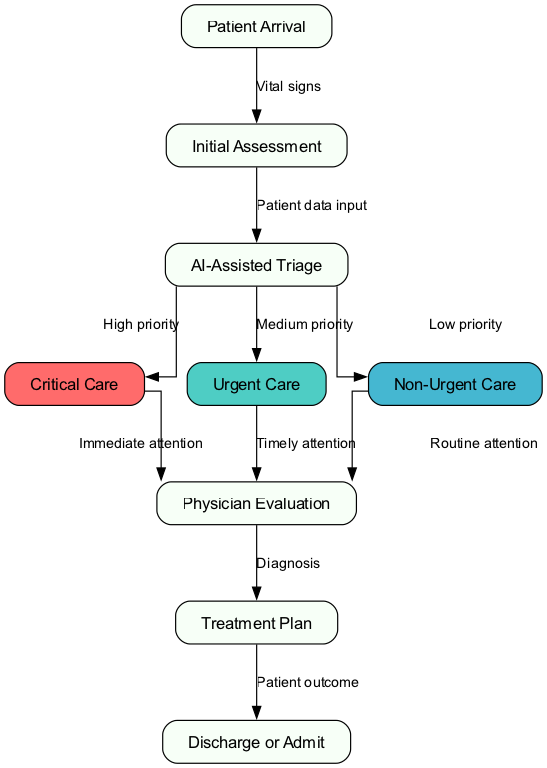What is the first step in the triage process? The flowchart begins with "Patient Arrival" as the first node in the triage process.
Answer: Patient Arrival How many nodes are present in this flowchart? By counting the distinct labeled elements in the flowchart, there are 9 nodes present.
Answer: 9 What type of care is given after "AI-Assisted Triage" if the patient is categorized as high priority? The flowchart directs high priority patients to "Critical Care" as indicated directly from "AI-Assisted Triage."
Answer: Critical Care What does the arrow between "7" and "8" signify? The arrow between nodes "7" (Physician Evaluation) and "8" (Treatment Plan) signifies that a diagnosis is made during the physician evaluation process, leading to developing a treatment plan.
Answer: Diagnosis If a patient requires routine attention, what is the next step after "AI-Assisted Triage"? For patients categorized under low priority by the "AI-Assisted Triage," the next step is to receive "Routine attention" from the physician following the triage process.
Answer: Routine attention What are the three care types represented in the flowchart? The flowchart categorizes care into three types: Critical Care, Urgent Care, and Non-Urgent Care as distinct end paths from the triage process.
Answer: Critical Care, Urgent Care, Non-Urgent Care Which node indicates a patient might be discharged or admitted? The flowchart specifies "Discharge or Admit" as the final decision point where patient outcomes are determined based on previous evaluations and treatment plans.
Answer: Discharge or Admit How does the process proceed from "Urgent Care" to "Physician Evaluation"? The edge labeled "Timely attention" connects "Urgent Care" to "Physician Evaluation," indicating the importance of evaluating patients who are categorized under urgent care promptly.
Answer: Timely attention 